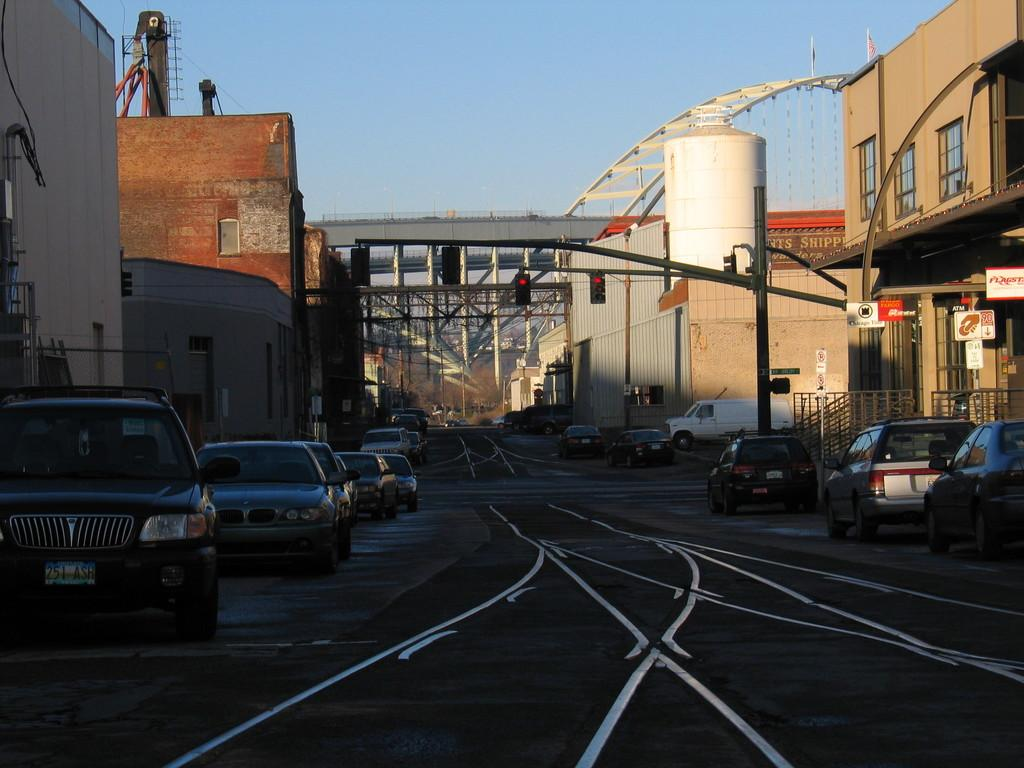What is the main feature of the image? There is a road in the image. What is happening on the road? Cars are moving on the road. What can be seen on both sides of the road? There are buildings on the right and left sides of the image. What is located in the middle of the image? Pillars are present in the middle of the image, and a flyover is visible. What type of disease is being treated at the amusement park in the image? There is no amusement park or disease mentioned in the image; it features a road with cars, buildings, pillars, and a flyover. 